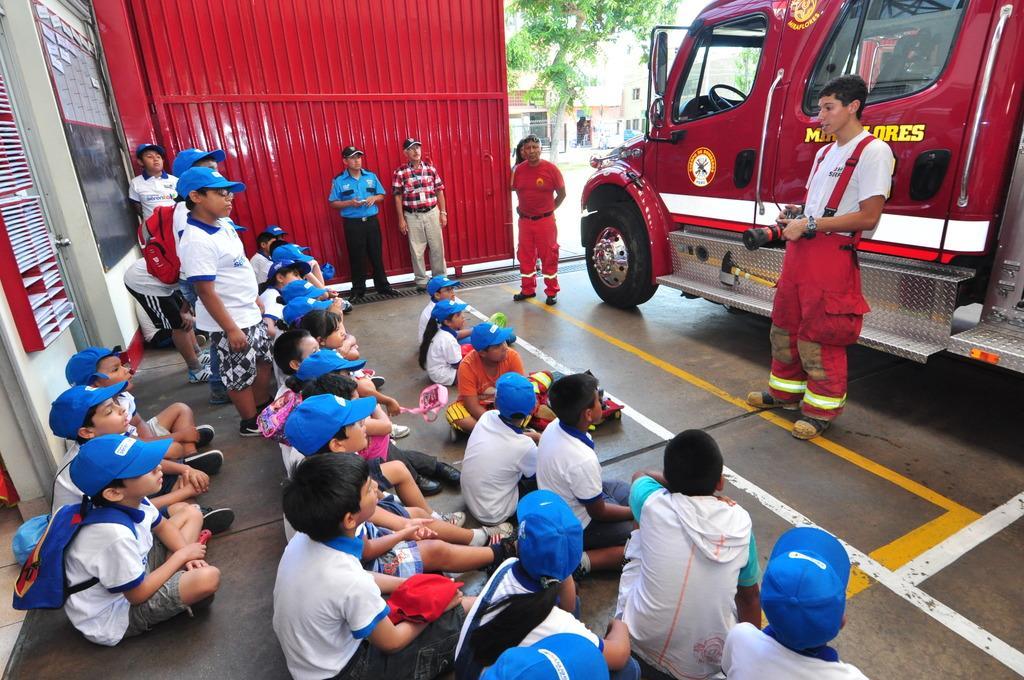Can you describe this image briefly? In this image we can see few persons are sitting and few persons are standing on the floor and among them few persons are carrying bags on the shoulders and a man is holding camera in his hands. We can see a metal door, objects on a rake board on the wall. In the background we can see a building and tree. 